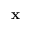Convert formula to latex. <formula><loc_0><loc_0><loc_500><loc_500>x</formula> 